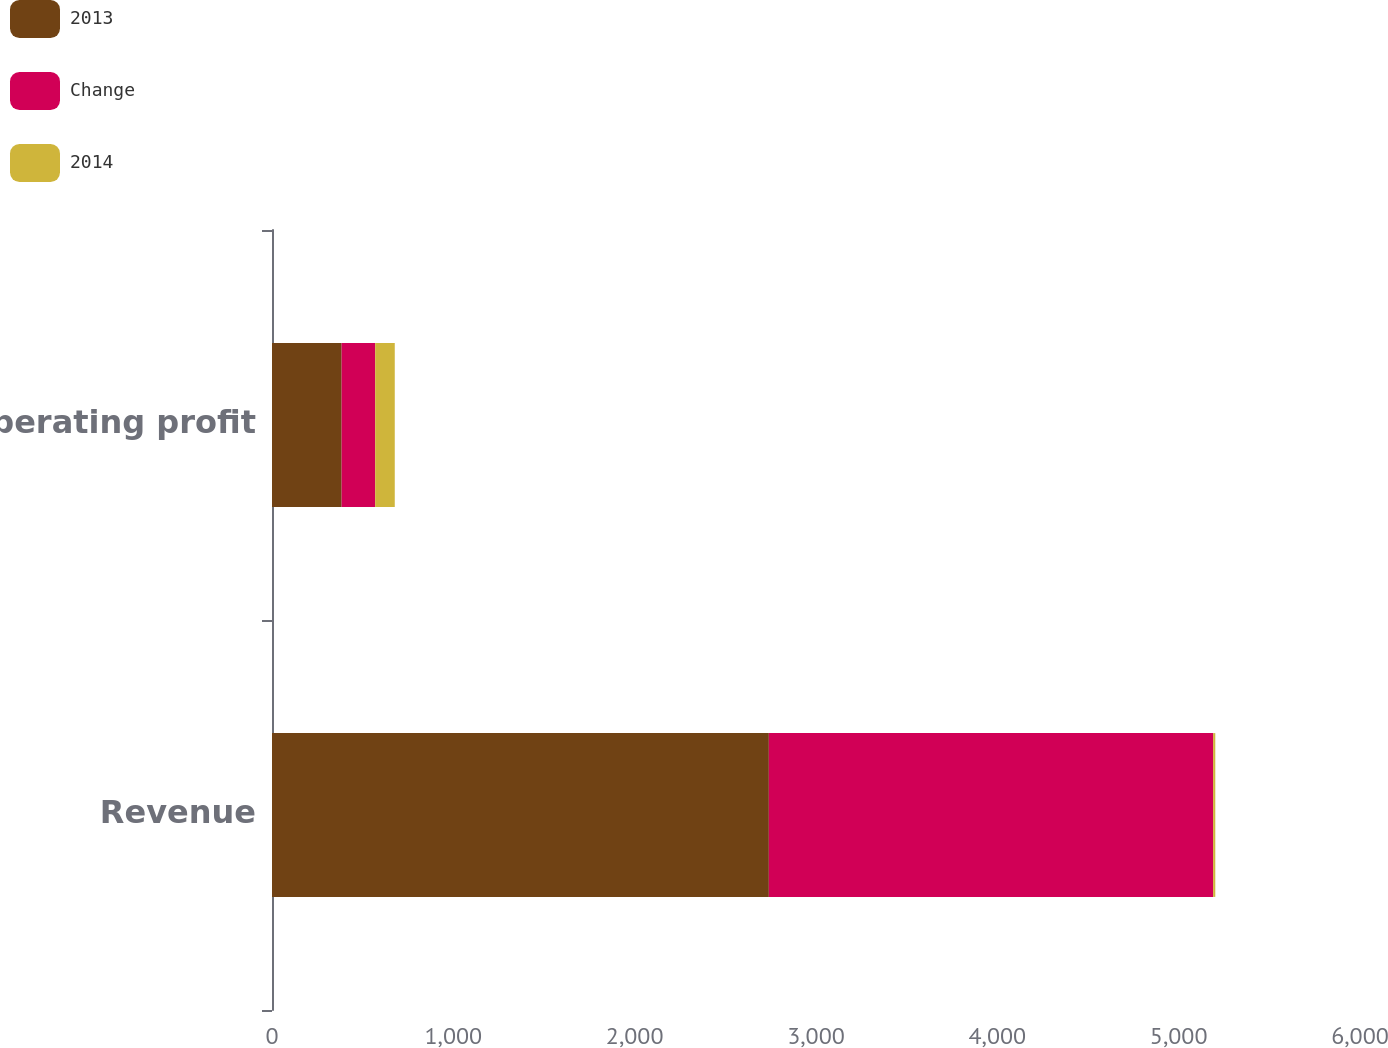<chart> <loc_0><loc_0><loc_500><loc_500><stacked_bar_chart><ecel><fcel>Revenue<fcel>Operating profit<nl><fcel>2013<fcel>2740<fcel>384<nl><fcel>Change<fcel>2450<fcel>185<nl><fcel>2014<fcel>12<fcel>108<nl></chart> 